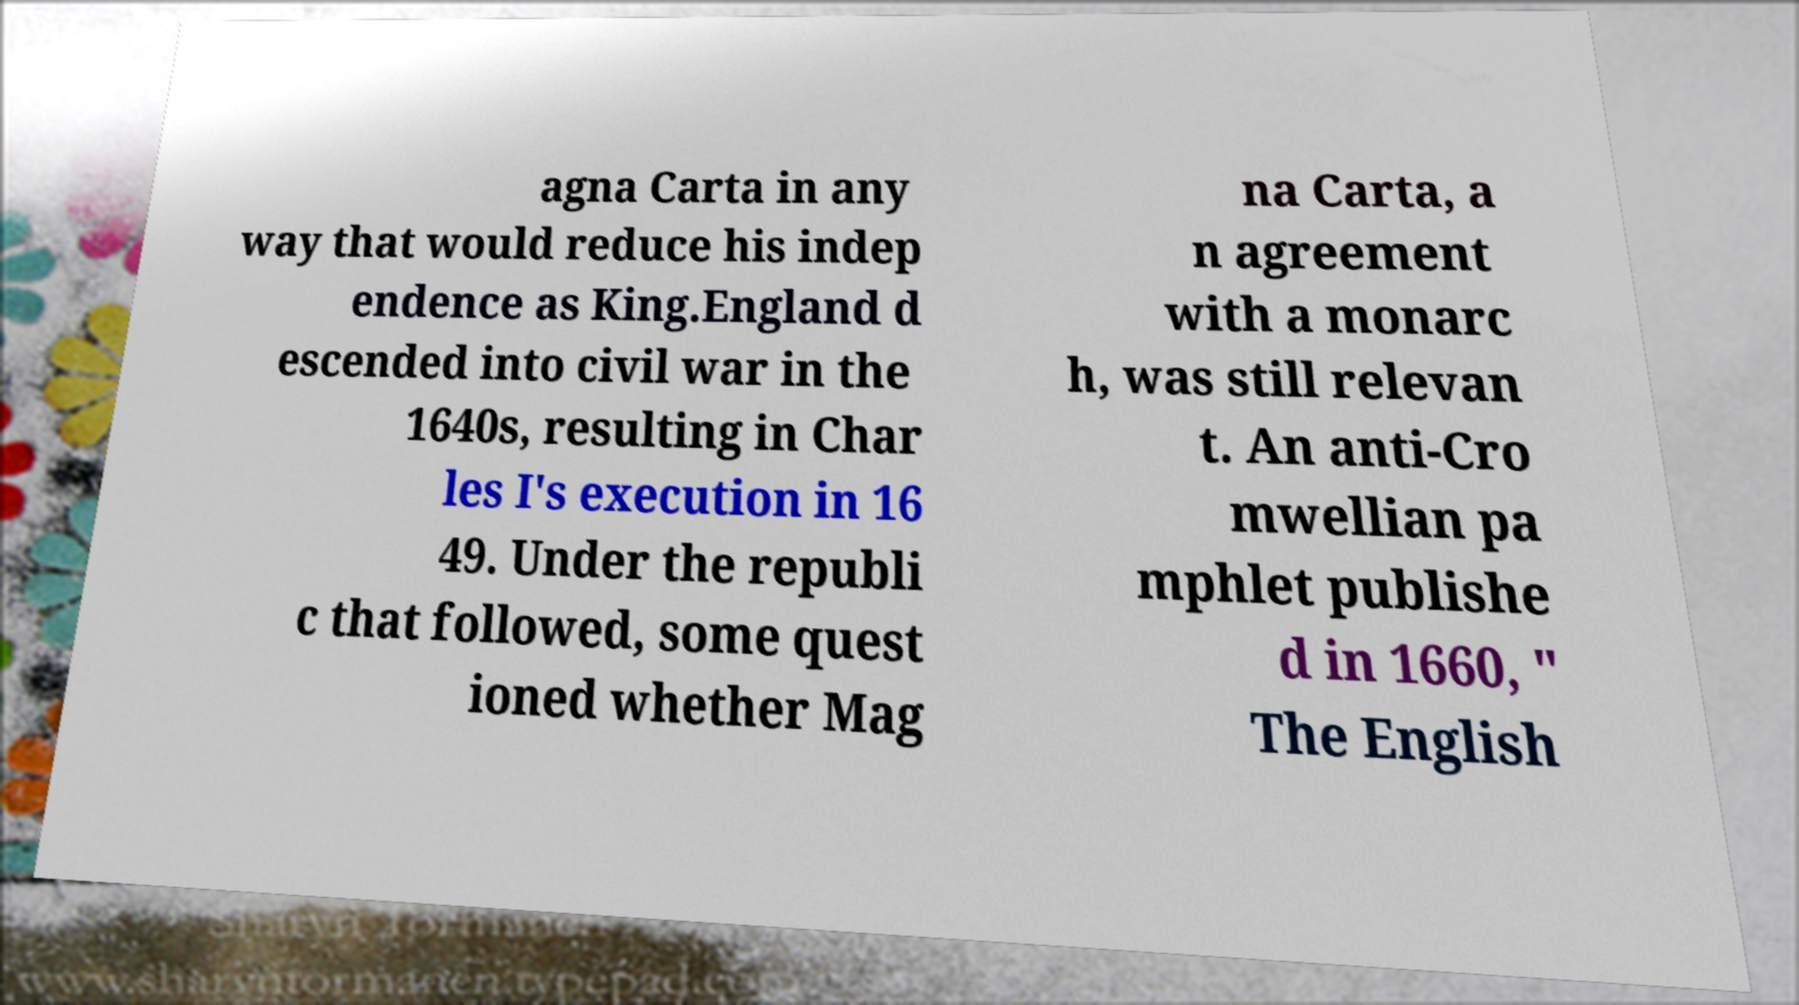Could you assist in decoding the text presented in this image and type it out clearly? agna Carta in any way that would reduce his indep endence as King.England d escended into civil war in the 1640s, resulting in Char les I's execution in 16 49. Under the republi c that followed, some quest ioned whether Mag na Carta, a n agreement with a monarc h, was still relevan t. An anti-Cro mwellian pa mphlet publishe d in 1660, " The English 